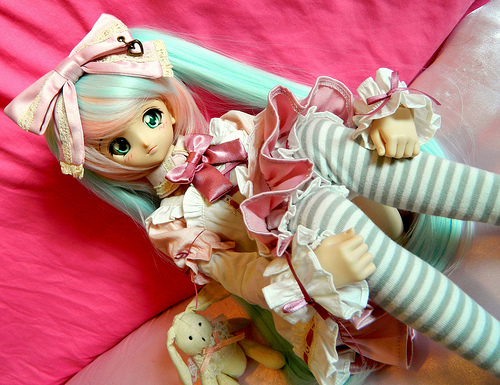<image>
Is the doll on the bunny? Yes. Looking at the image, I can see the doll is positioned on top of the bunny, with the bunny providing support. Is there a bunny to the right of the doll? Yes. From this viewpoint, the bunny is positioned to the right side relative to the doll. Is there a doll next to the toy bunny? Yes. The doll is positioned adjacent to the toy bunny, located nearby in the same general area. 